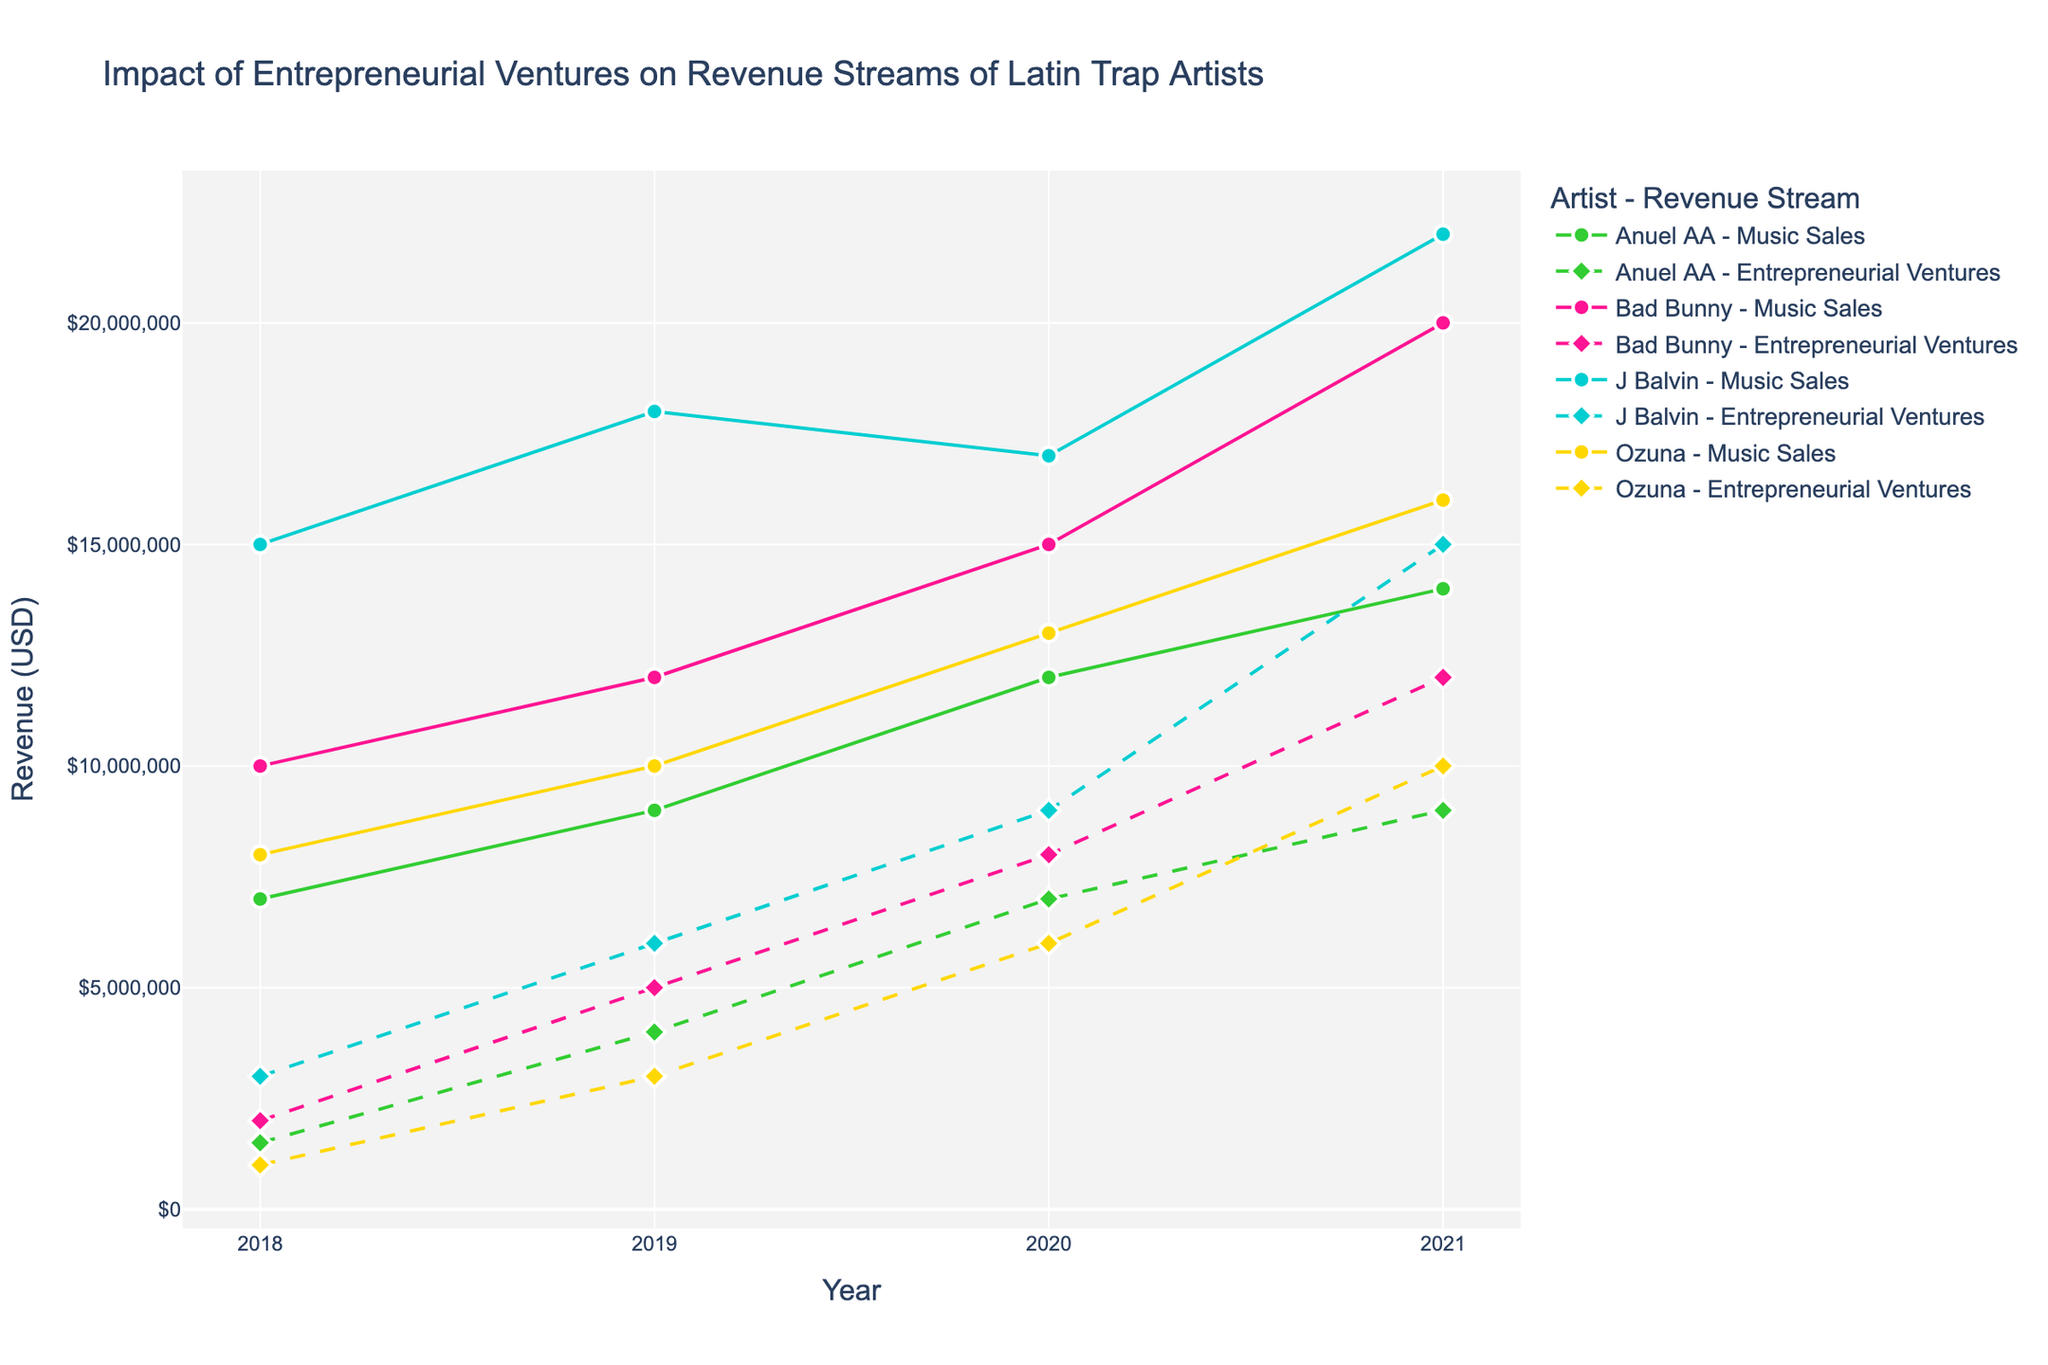Which artist had the highest revenue from Music Sales in 2021? To find the artist with the highest revenue from Music Sales in 2021, look at the data points for that year on the figure for all artists' Music Sales. The highest value is J Balvin’s Music Sales, which is $22,000,000.
Answer: J Balvin How much did Bad Bunny's revenue from Entrepreneurial Ventures increase from 2018 to 2021? Identify Bad Bunny's Entrepreneurial Ventures revenue in 2018 ($2,000,000) and 2021 ($12,000,000). Calculate the increase by subtracting 2018's value from 2021's value: $12,000,000 - $2,000,000 = $10,000,000.
Answer: $10,000,000 Which artist experienced the smallest revenue from Entrepreneurial Ventures in 2018? Examine the Entrepreneurial Ventures data for 2018 for all artists. The smallest value is Ozuna’s Entrepreneurial Ventures in 2018, which is $1,000,000.
Answer: Ozuna Between 2018 and 2021, which artist had the highest total increase in Entrepreneurial Ventures revenue? Calculate the increase for each artist by finding the difference between their 2021 and 2018 revenues from Entrepreneurial Ventures: 
- Bad Bunny: $12,000,000 - $2,000,000 = $10,000,000 
- J Balvin: $15,000,000 - $3,000,000 = $12,000,000 
- Ozuna: $10,000,000 - $1,000,000 = $9,000,000 
- Anuel AA: $9,000,000 - $1,500,000 = $7,500,000 
J Balvin has the highest increase.
Answer: J Balvin By how much did Ozuna's Music Sales revenue grow, on average, from 2018 to 2021? Calculate the yearly growth by subtracting the 2018 revenue from the 2021 revenue and then divide by the number of years (3): ($16,000,000 - $8,000,000) / 3 = $2,666,666.67.
Answer: $2,666,667 Which artist had the largest difference in revenue between Music Sales and Entrepreneurial Ventures in 2021? Find the difference between Music Sales and Entrepreneurial Ventures for each artist in 2021: 
- Bad Bunny: $20,000,000 - $12,000,000 = $8,000,000 
- J Balvin: $22,000,000 - $15,000,000 = $7,000,000 
- Ozuna: $16,000,000 - $10,000,000 = $6,000,000 
- Anuel AA: $14,000,000 - $9,000,000 = $5,000,000 
Bad Bunny has the largest difference.
Answer: Bad Bunny Which artist achieved a higher increase in Music Sales in 2020 compared to 2019? Calculate the increase in Music Sales for each artist from 2019 to 2020:
- Bad Bunny: $15,000,000 - $12,000,000 = $3,000,000
- J Balvin: $17,000,000 - $18,000,000 = -$1,000,000 (decrease)
- Ozuna: $13,000,000 - $10,000,000 = $3,000,000
- Anuel AA: $12,000,000 - $9,000,000 = $3,000,000
Bad Bunny, Ozuna, and Anuel AA had the same $3,000,000 increase.
Answer: Bad Bunny, Ozuna, Anuel AA In 2018, which had a higher revenue for J Balvin: Music Sales or Entrepreneurial Ventures? By how much? Compare J Balvin’s 2018 revenues for Music Sales ($15,000,000) and Entrepreneurial Ventures ($3,000,000). Music Sales is higher. The difference is $15,000,000 - $3,000,000 = $12,000,000.
Answer: Music Sales, $12,000,000 Which artist had a Revenue Stream that was above $10,000,000 in both Music Sales and Entrepreneurial Ventures in 2020? Check each artist's 2020 revenue in both Music Sales and Entrepreneurial Ventures:
- Bad Bunny: Music Sales $15,000,000, Entrepreneurial Ventures $8,000,000
- J Balvin: Music Sales $17,000,000, Entrepreneurial Ventures $9,000,000
- Ozuna: Music Sales $13,000,000, Entrepreneurial Ventures $6,000,000
- Anuel AA: Music Sales $12,000,000, Entrepreneurial Ventures $7,000,000
None of the artists had both streams above $10,000,000 in 2020.
Answer: None 